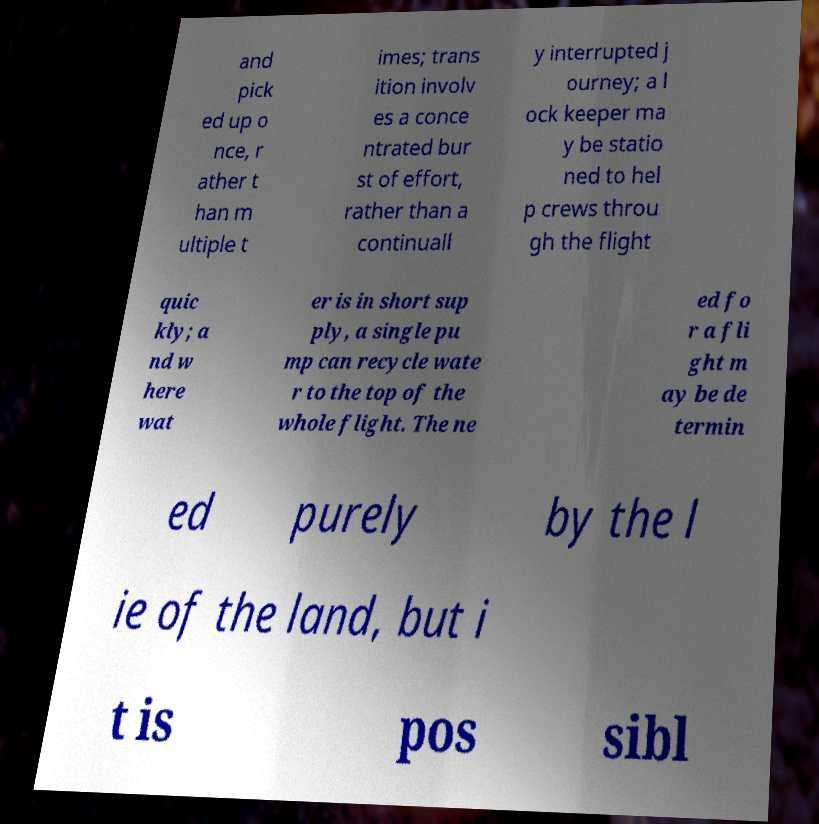Can you accurately transcribe the text from the provided image for me? and pick ed up o nce, r ather t han m ultiple t imes; trans ition involv es a conce ntrated bur st of effort, rather than a continuall y interrupted j ourney; a l ock keeper ma y be statio ned to hel p crews throu gh the flight quic kly; a nd w here wat er is in short sup ply, a single pu mp can recycle wate r to the top of the whole flight. The ne ed fo r a fli ght m ay be de termin ed purely by the l ie of the land, but i t is pos sibl 